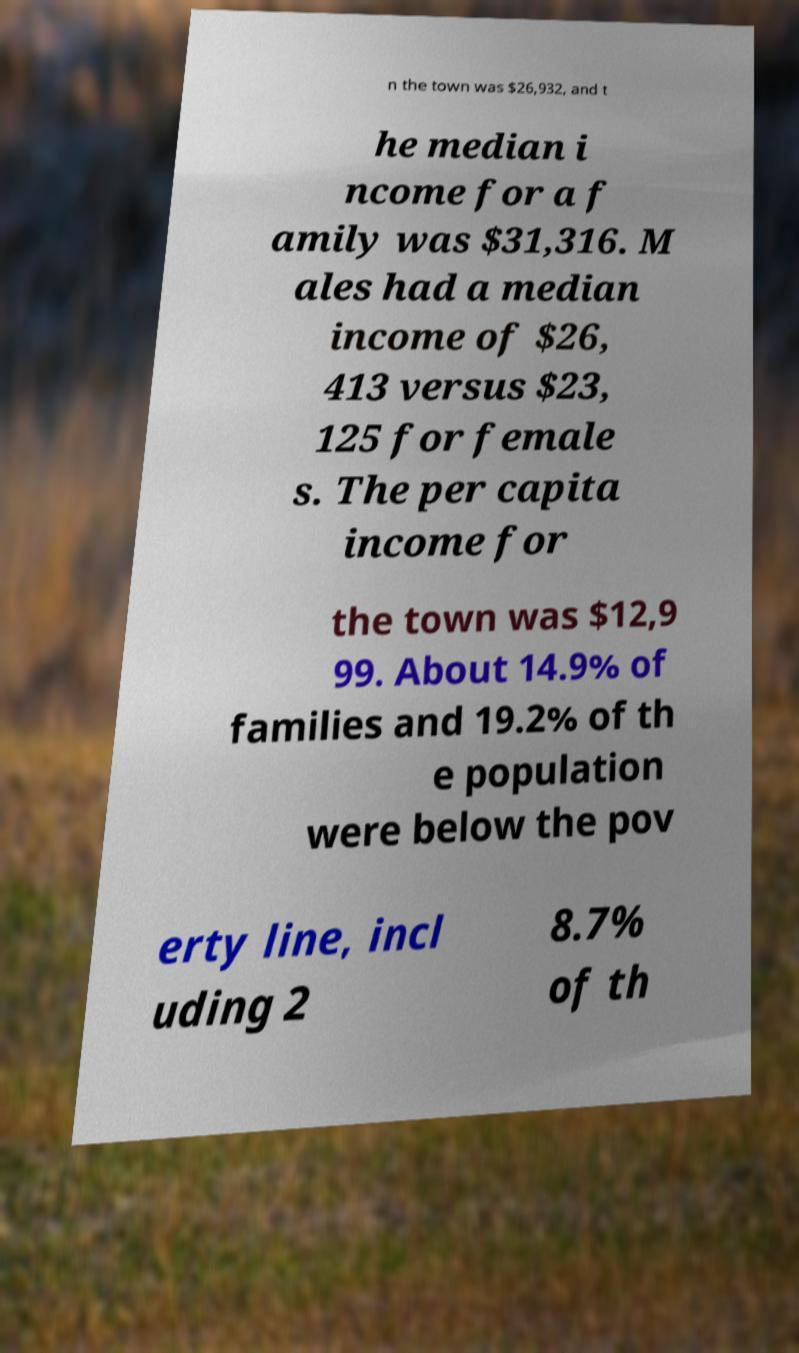Can you read and provide the text displayed in the image?This photo seems to have some interesting text. Can you extract and type it out for me? n the town was $26,932, and t he median i ncome for a f amily was $31,316. M ales had a median income of $26, 413 versus $23, 125 for female s. The per capita income for the town was $12,9 99. About 14.9% of families and 19.2% of th e population were below the pov erty line, incl uding 2 8.7% of th 